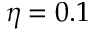<formula> <loc_0><loc_0><loc_500><loc_500>\eta = 0 . 1</formula> 